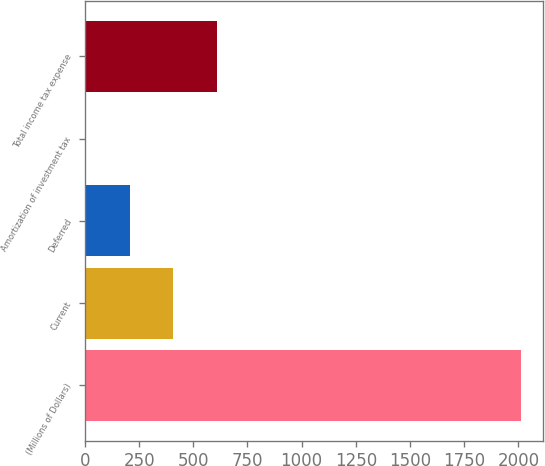Convert chart to OTSL. <chart><loc_0><loc_0><loc_500><loc_500><bar_chart><fcel>(Millions of Dollars)<fcel>Current<fcel>Deferred<fcel>Amortization of investment tax<fcel>Total income tax expense<nl><fcel>2013<fcel>406.6<fcel>205.8<fcel>5<fcel>607.4<nl></chart> 